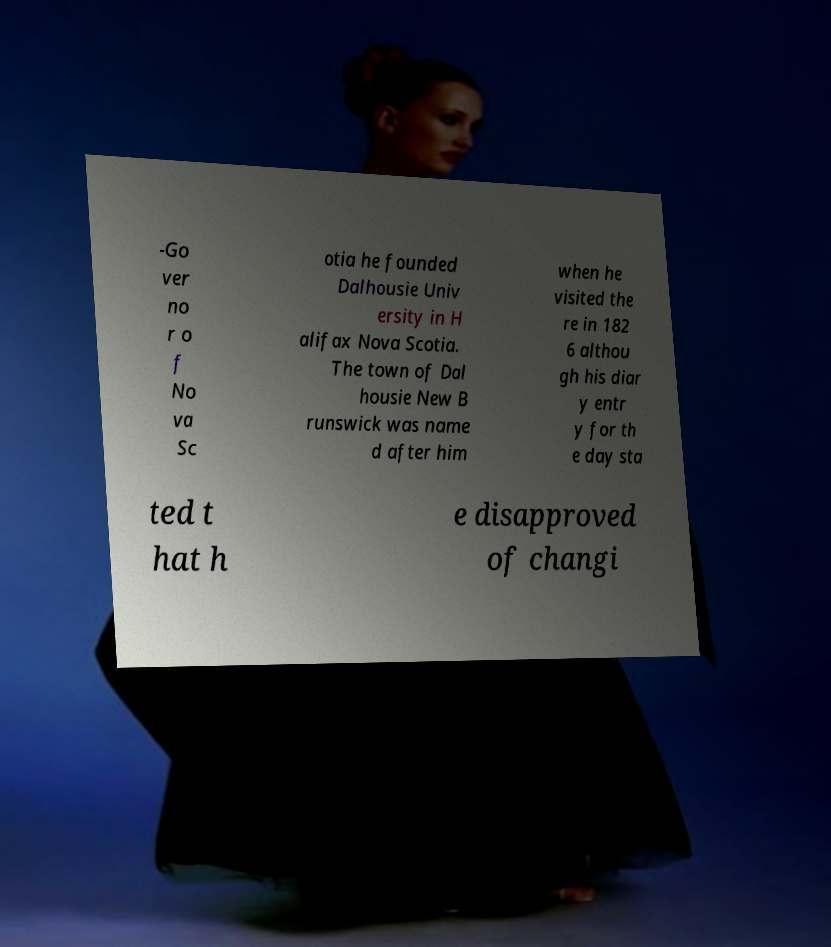Please read and relay the text visible in this image. What does it say? -Go ver no r o f No va Sc otia he founded Dalhousie Univ ersity in H alifax Nova Scotia. The town of Dal housie New B runswick was name d after him when he visited the re in 182 6 althou gh his diar y entr y for th e day sta ted t hat h e disapproved of changi 